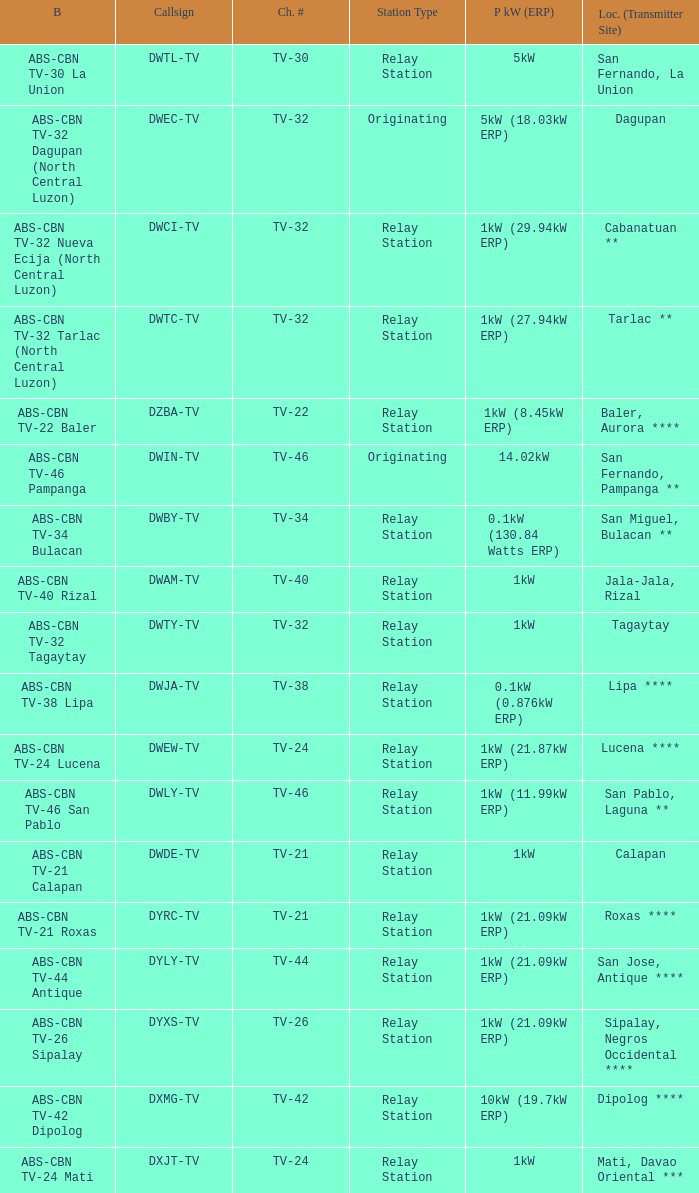Could you help me parse every detail presented in this table? {'header': ['B', 'Callsign', 'Ch. #', 'Station Type', 'P kW (ERP)', 'Loc. (Transmitter Site)'], 'rows': [['ABS-CBN TV-30 La Union', 'DWTL-TV', 'TV-30', 'Relay Station', '5kW', 'San Fernando, La Union'], ['ABS-CBN TV-32 Dagupan (North Central Luzon)', 'DWEC-TV', 'TV-32', 'Originating', '5kW (18.03kW ERP)', 'Dagupan'], ['ABS-CBN TV-32 Nueva Ecija (North Central Luzon)', 'DWCI-TV', 'TV-32', 'Relay Station', '1kW (29.94kW ERP)', 'Cabanatuan **'], ['ABS-CBN TV-32 Tarlac (North Central Luzon)', 'DWTC-TV', 'TV-32', 'Relay Station', '1kW (27.94kW ERP)', 'Tarlac **'], ['ABS-CBN TV-22 Baler', 'DZBA-TV', 'TV-22', 'Relay Station', '1kW (8.45kW ERP)', 'Baler, Aurora ****'], ['ABS-CBN TV-46 Pampanga', 'DWIN-TV', 'TV-46', 'Originating', '14.02kW', 'San Fernando, Pampanga **'], ['ABS-CBN TV-34 Bulacan', 'DWBY-TV', 'TV-34', 'Relay Station', '0.1kW (130.84 Watts ERP)', 'San Miguel, Bulacan **'], ['ABS-CBN TV-40 Rizal', 'DWAM-TV', 'TV-40', 'Relay Station', '1kW', 'Jala-Jala, Rizal'], ['ABS-CBN TV-32 Tagaytay', 'DWTY-TV', 'TV-32', 'Relay Station', '1kW', 'Tagaytay'], ['ABS-CBN TV-38 Lipa', 'DWJA-TV', 'TV-38', 'Relay Station', '0.1kW (0.876kW ERP)', 'Lipa ****'], ['ABS-CBN TV-24 Lucena', 'DWEW-TV', 'TV-24', 'Relay Station', '1kW (21.87kW ERP)', 'Lucena ****'], ['ABS-CBN TV-46 San Pablo', 'DWLY-TV', 'TV-46', 'Relay Station', '1kW (11.99kW ERP)', 'San Pablo, Laguna **'], ['ABS-CBN TV-21 Calapan', 'DWDE-TV', 'TV-21', 'Relay Station', '1kW', 'Calapan'], ['ABS-CBN TV-21 Roxas', 'DYRC-TV', 'TV-21', 'Relay Station', '1kW (21.09kW ERP)', 'Roxas ****'], ['ABS-CBN TV-44 Antique', 'DYLY-TV', 'TV-44', 'Relay Station', '1kW (21.09kW ERP)', 'San Jose, Antique ****'], ['ABS-CBN TV-26 Sipalay', 'DYXS-TV', 'TV-26', 'Relay Station', '1kW (21.09kW ERP)', 'Sipalay, Negros Occidental ****'], ['ABS-CBN TV-42 Dipolog', 'DXMG-TV', 'TV-42', 'Relay Station', '10kW (19.7kW ERP)', 'Dipolog ****'], ['ABS-CBN TV-24 Mati', 'DXJT-TV', 'TV-24', 'Relay Station', '1kW', 'Mati, Davao Oriental ***']]} What is the branding of the callsign DWCI-TV? ABS-CBN TV-32 Nueva Ecija (North Central Luzon). 